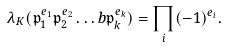<formula> <loc_0><loc_0><loc_500><loc_500>\lambda _ { K } ( \mathfrak { p } _ { 1 } ^ { e _ { 1 } } \mathfrak { p } _ { 2 } ^ { e _ { 2 } } \dots b \mathfrak { p } _ { k } ^ { e _ { k } } ) = \prod _ { i } ( - 1 ) ^ { e _ { i } } .</formula> 